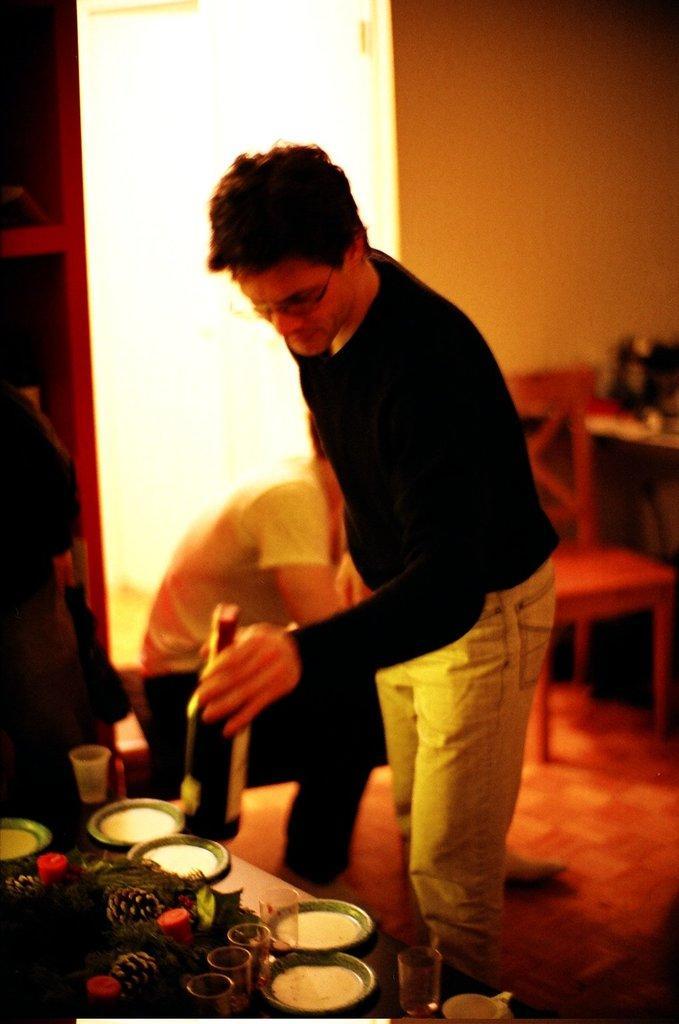In one or two sentences, can you explain what this image depicts? In this picture we can see a man is standing and holding a bottle, on the left side there are some glasses and other things, in the background we can see another person is sitting, on the right side there is a chair and a table, we can also see a wall in the background. 